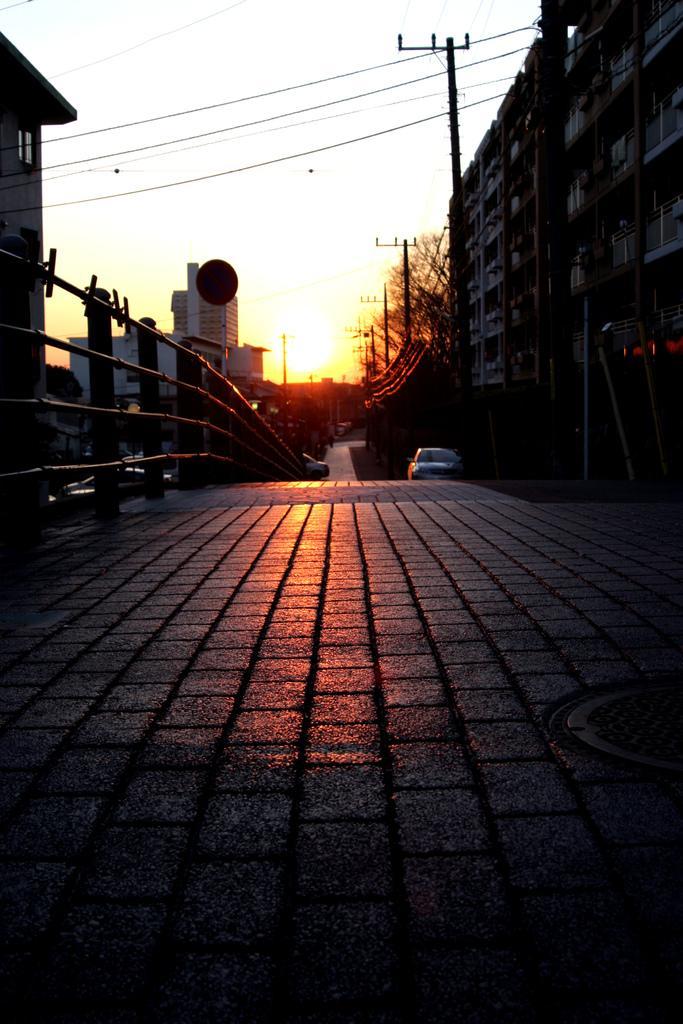Describe this image in one or two sentences. There is a car on the road as we can see at the bottom of this image. We can see buildings, trees and poles in the middle of this image and the sky is in the background. 